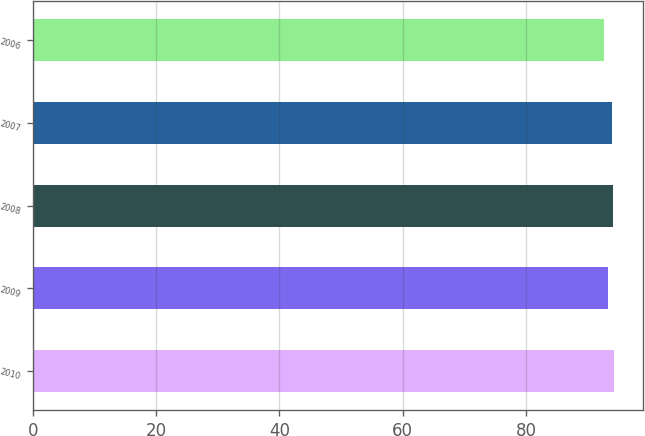<chart> <loc_0><loc_0><loc_500><loc_500><bar_chart><fcel>2010<fcel>2009<fcel>2008<fcel>2007<fcel>2006<nl><fcel>94.32<fcel>93.3<fcel>94.16<fcel>94<fcel>92.7<nl></chart> 